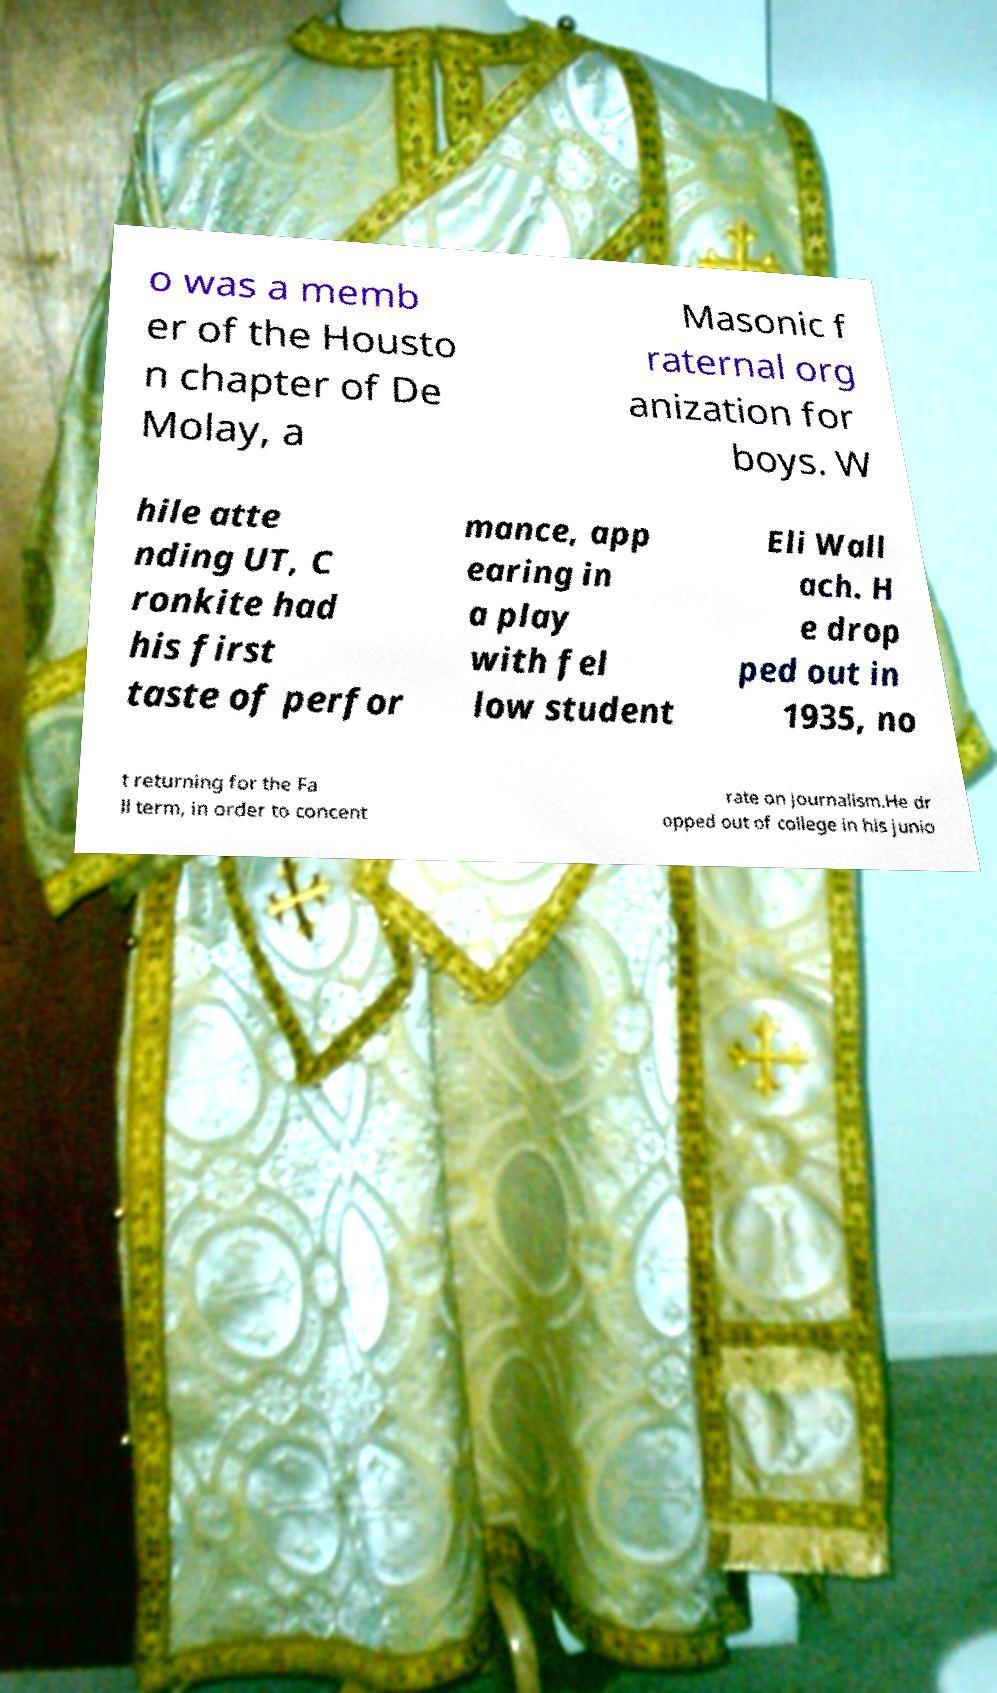Please read and relay the text visible in this image. What does it say? o was a memb er of the Housto n chapter of De Molay, a Masonic f raternal org anization for boys. W hile atte nding UT, C ronkite had his first taste of perfor mance, app earing in a play with fel low student Eli Wall ach. H e drop ped out in 1935, no t returning for the Fa ll term, in order to concent rate on journalism.He dr opped out of college in his junio 